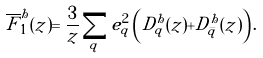Convert formula to latex. <formula><loc_0><loc_0><loc_500><loc_500>\overline { F } ^ { h } _ { 1 } ( z ) = \frac { 3 } { z } \sum _ { q } e _ { q } ^ { 2 } \left ( D _ { q } ^ { h } ( z ) + D _ { \bar { q } } ^ { h } ( z ) \right ) .</formula> 